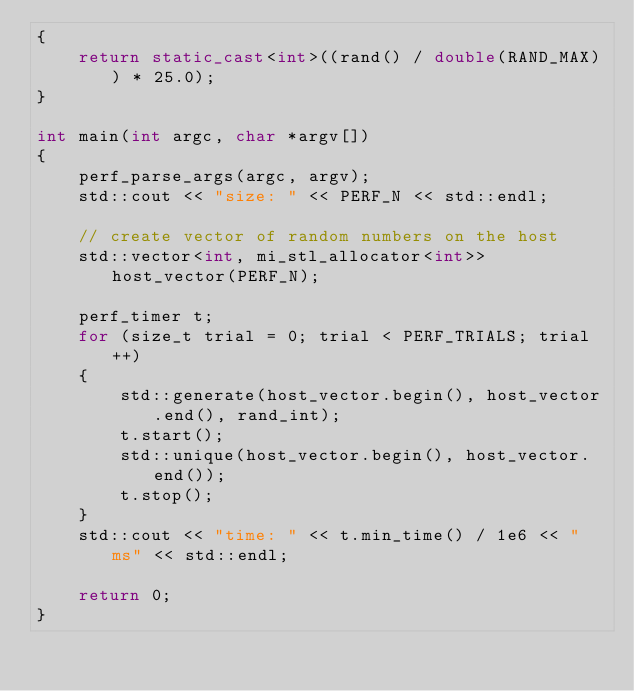<code> <loc_0><loc_0><loc_500><loc_500><_C++_>{
    return static_cast<int>((rand() / double(RAND_MAX)) * 25.0);
}

int main(int argc, char *argv[])
{
    perf_parse_args(argc, argv);
    std::cout << "size: " << PERF_N << std::endl;

    // create vector of random numbers on the host
    std::vector<int, mi_stl_allocator<int>> host_vector(PERF_N);

    perf_timer t;
    for (size_t trial = 0; trial < PERF_TRIALS; trial++)
    {
        std::generate(host_vector.begin(), host_vector.end(), rand_int);
        t.start();
        std::unique(host_vector.begin(), host_vector.end());
        t.stop();
    }
    std::cout << "time: " << t.min_time() / 1e6 << " ms" << std::endl;

    return 0;
}
</code> 